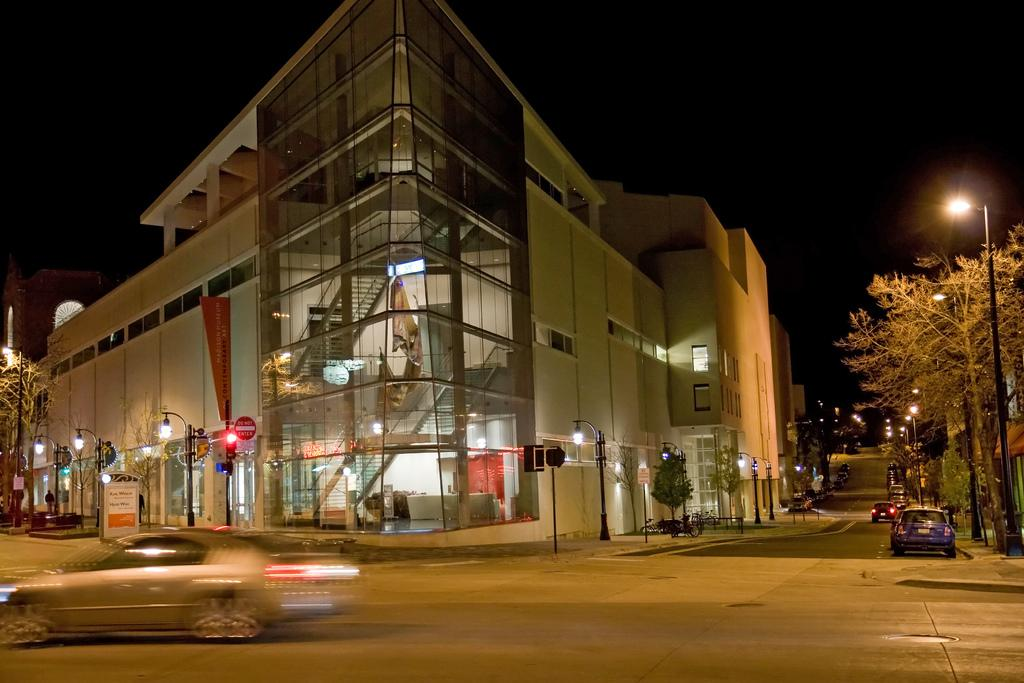What is located in the center of the image? There are buildings, poles, lights, and trees in the center of the image. What type of vehicles can be seen in the image? There are vehicles in the image. What is at the bottom of the image? There is a road at the bottom of the image. What is visible at the top of the image? The sky is visible at the top of the image. Can you see a crook blowing bubbles with their tongue in the image? There is no crook or bubbles present in the image. What color is the tongue of the person in the image? There is no person visible in the image, so it is not possible to determine the color of their tongue. 